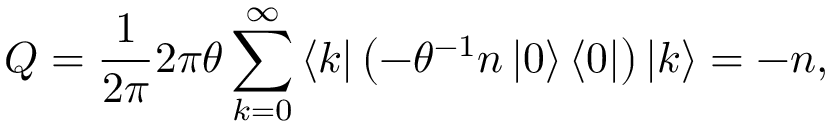Convert formula to latex. <formula><loc_0><loc_0><loc_500><loc_500>Q = \frac { 1 } { 2 \pi } 2 \pi \theta \sum _ { k = 0 } ^ { \infty } \left \langle k \right | \left ( - \theta ^ { - 1 } n \left | 0 \right \rangle \left \langle 0 \right | \right ) \left | k \right \rangle = - n ,</formula> 